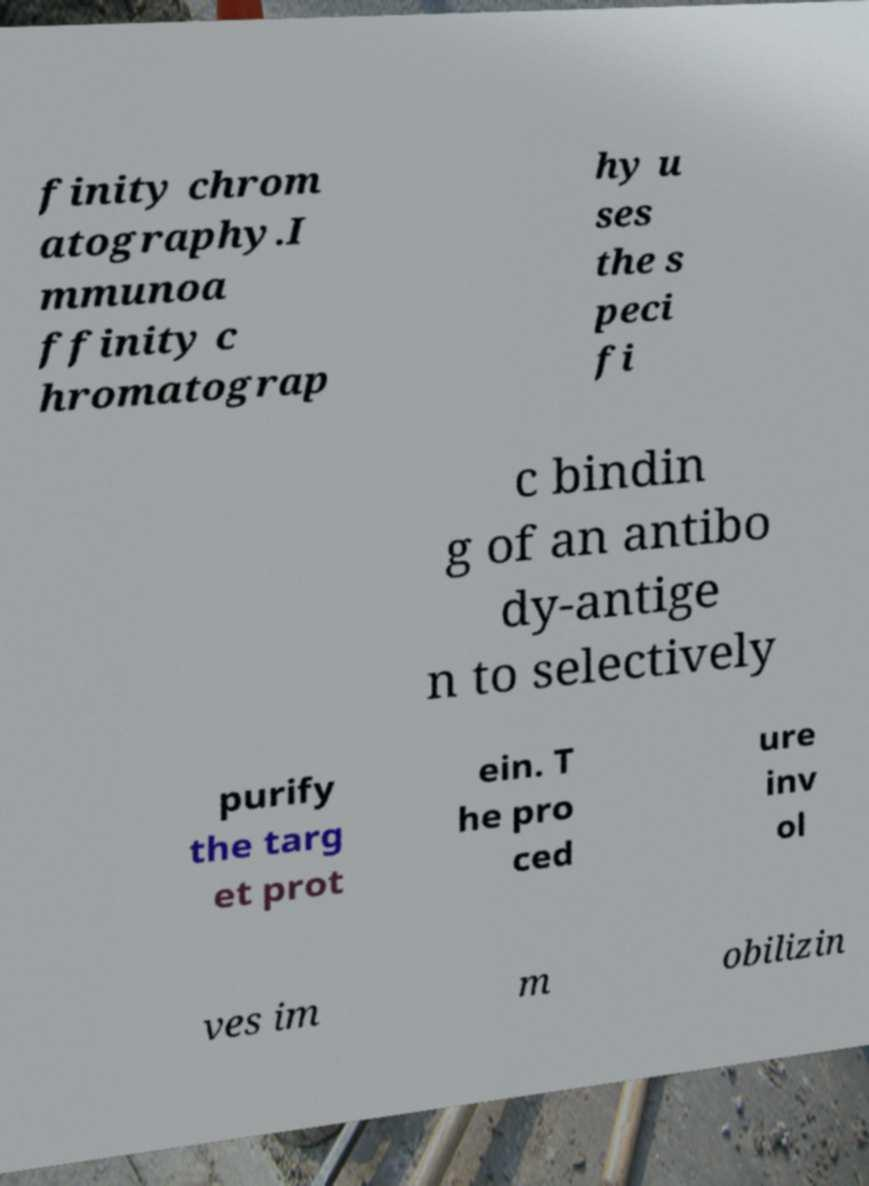Please read and relay the text visible in this image. What does it say? finity chrom atography.I mmunoa ffinity c hromatograp hy u ses the s peci fi c bindin g of an antibo dy-antige n to selectively purify the targ et prot ein. T he pro ced ure inv ol ves im m obilizin 